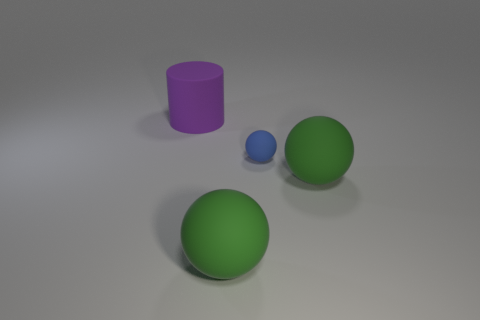Subtract all large green matte spheres. How many spheres are left? 1 Subtract all cyan cubes. How many green spheres are left? 2 Add 3 big gray metallic cubes. How many objects exist? 7 Subtract all spheres. How many objects are left? 1 Subtract all blocks. Subtract all tiny things. How many objects are left? 3 Add 4 green balls. How many green balls are left? 6 Add 3 big green objects. How many big green objects exist? 5 Subtract 0 gray cylinders. How many objects are left? 4 Subtract all blue balls. Subtract all red cylinders. How many balls are left? 2 